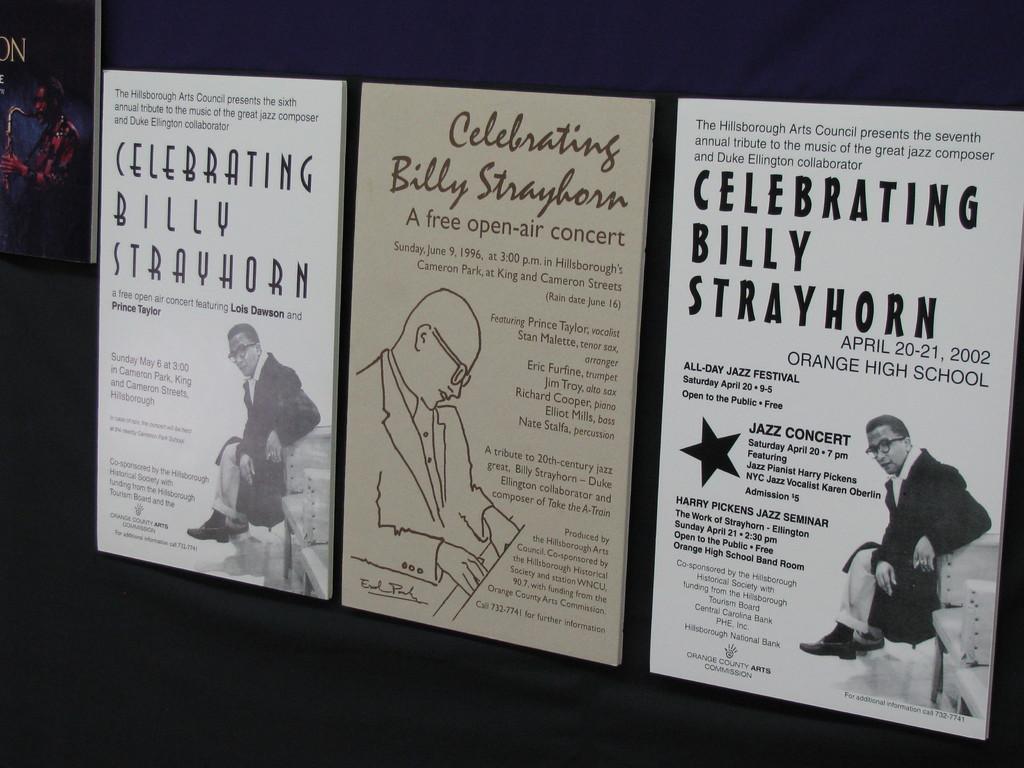Are those concert posters of billy strayhorn?
Offer a terse response. Yes. 